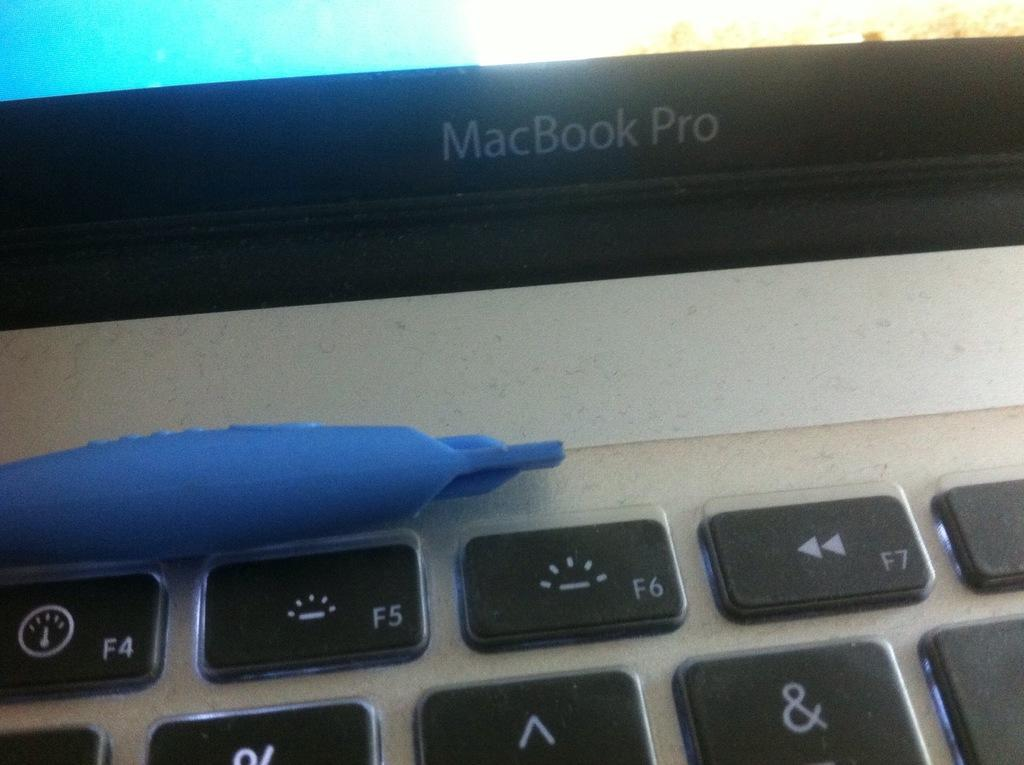What is the main subject in the foreground of the image? There is a laptop in the foreground of the image. What can be seen on the laptop? There is an object visible on the laptop. How much pleasure does the argument on the laptop provide? There is no mention of an argument or pleasure in the image, as it only features a laptop with an object visible on it. 